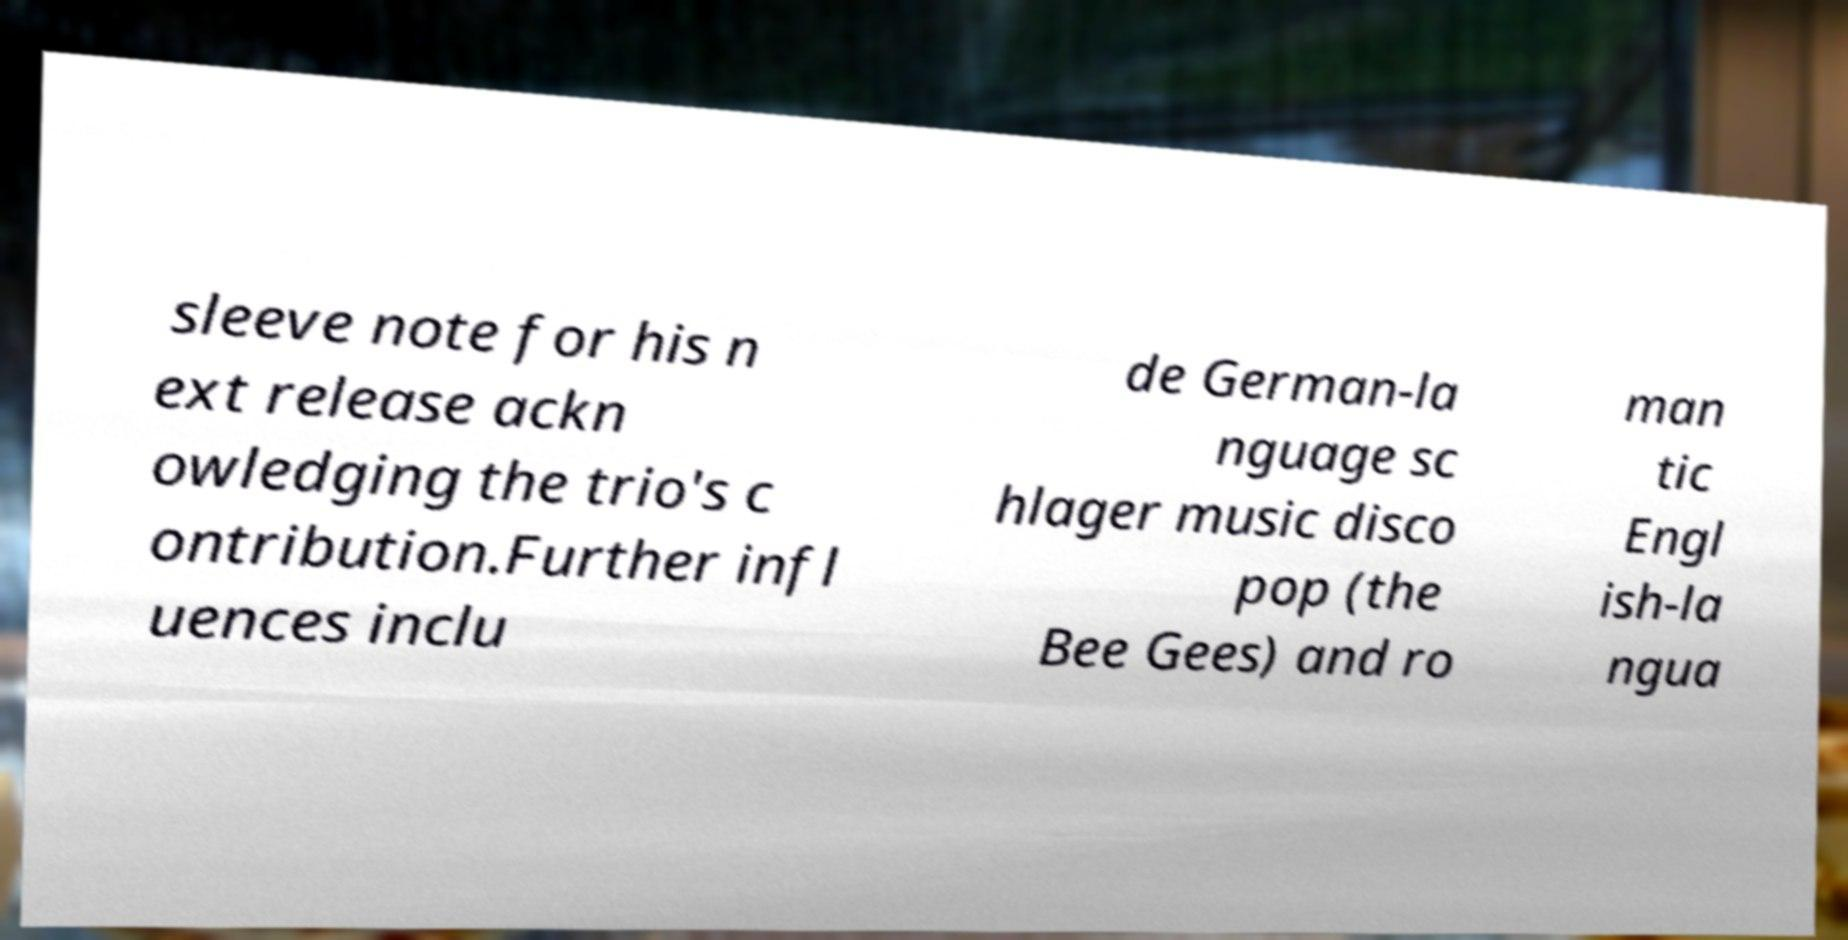Could you assist in decoding the text presented in this image and type it out clearly? sleeve note for his n ext release ackn owledging the trio's c ontribution.Further infl uences inclu de German-la nguage sc hlager music disco pop (the Bee Gees) and ro man tic Engl ish-la ngua 